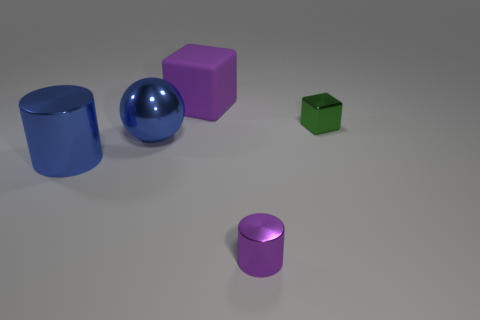What materials do the objects in the image appear to be made of? The objects in the image appear to be made of different materials. The blue cylinder and the blue sphere likely are made of a reflective metallic material, the purple cube and cylinder seem to be matte and possibly made of plastic or rubber, and the green cube looks like it could be either metallic or plastic with a matte finish. 